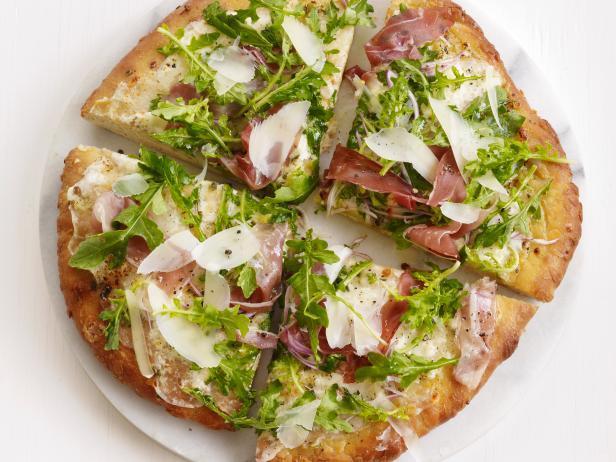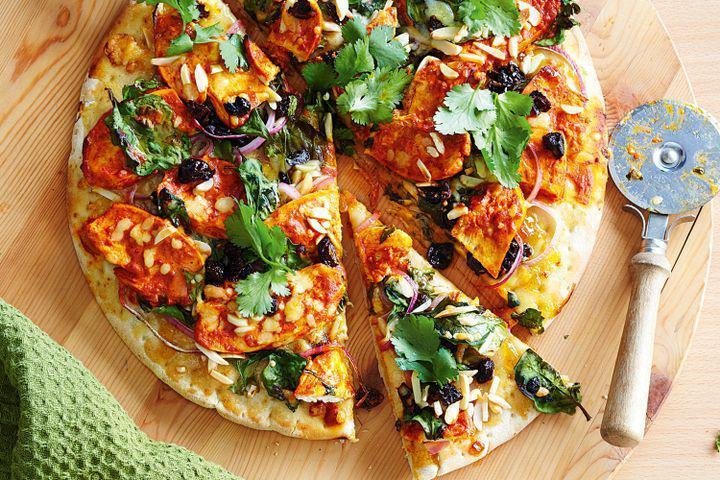The first image is the image on the left, the second image is the image on the right. Given the left and right images, does the statement "There are whole tomatoes." hold true? Answer yes or no. No. The first image is the image on the left, the second image is the image on the right. Examine the images to the left and right. Is the description "There are multiple pizzas in one of the images and only one pizza in the other image." accurate? Answer yes or no. No. 